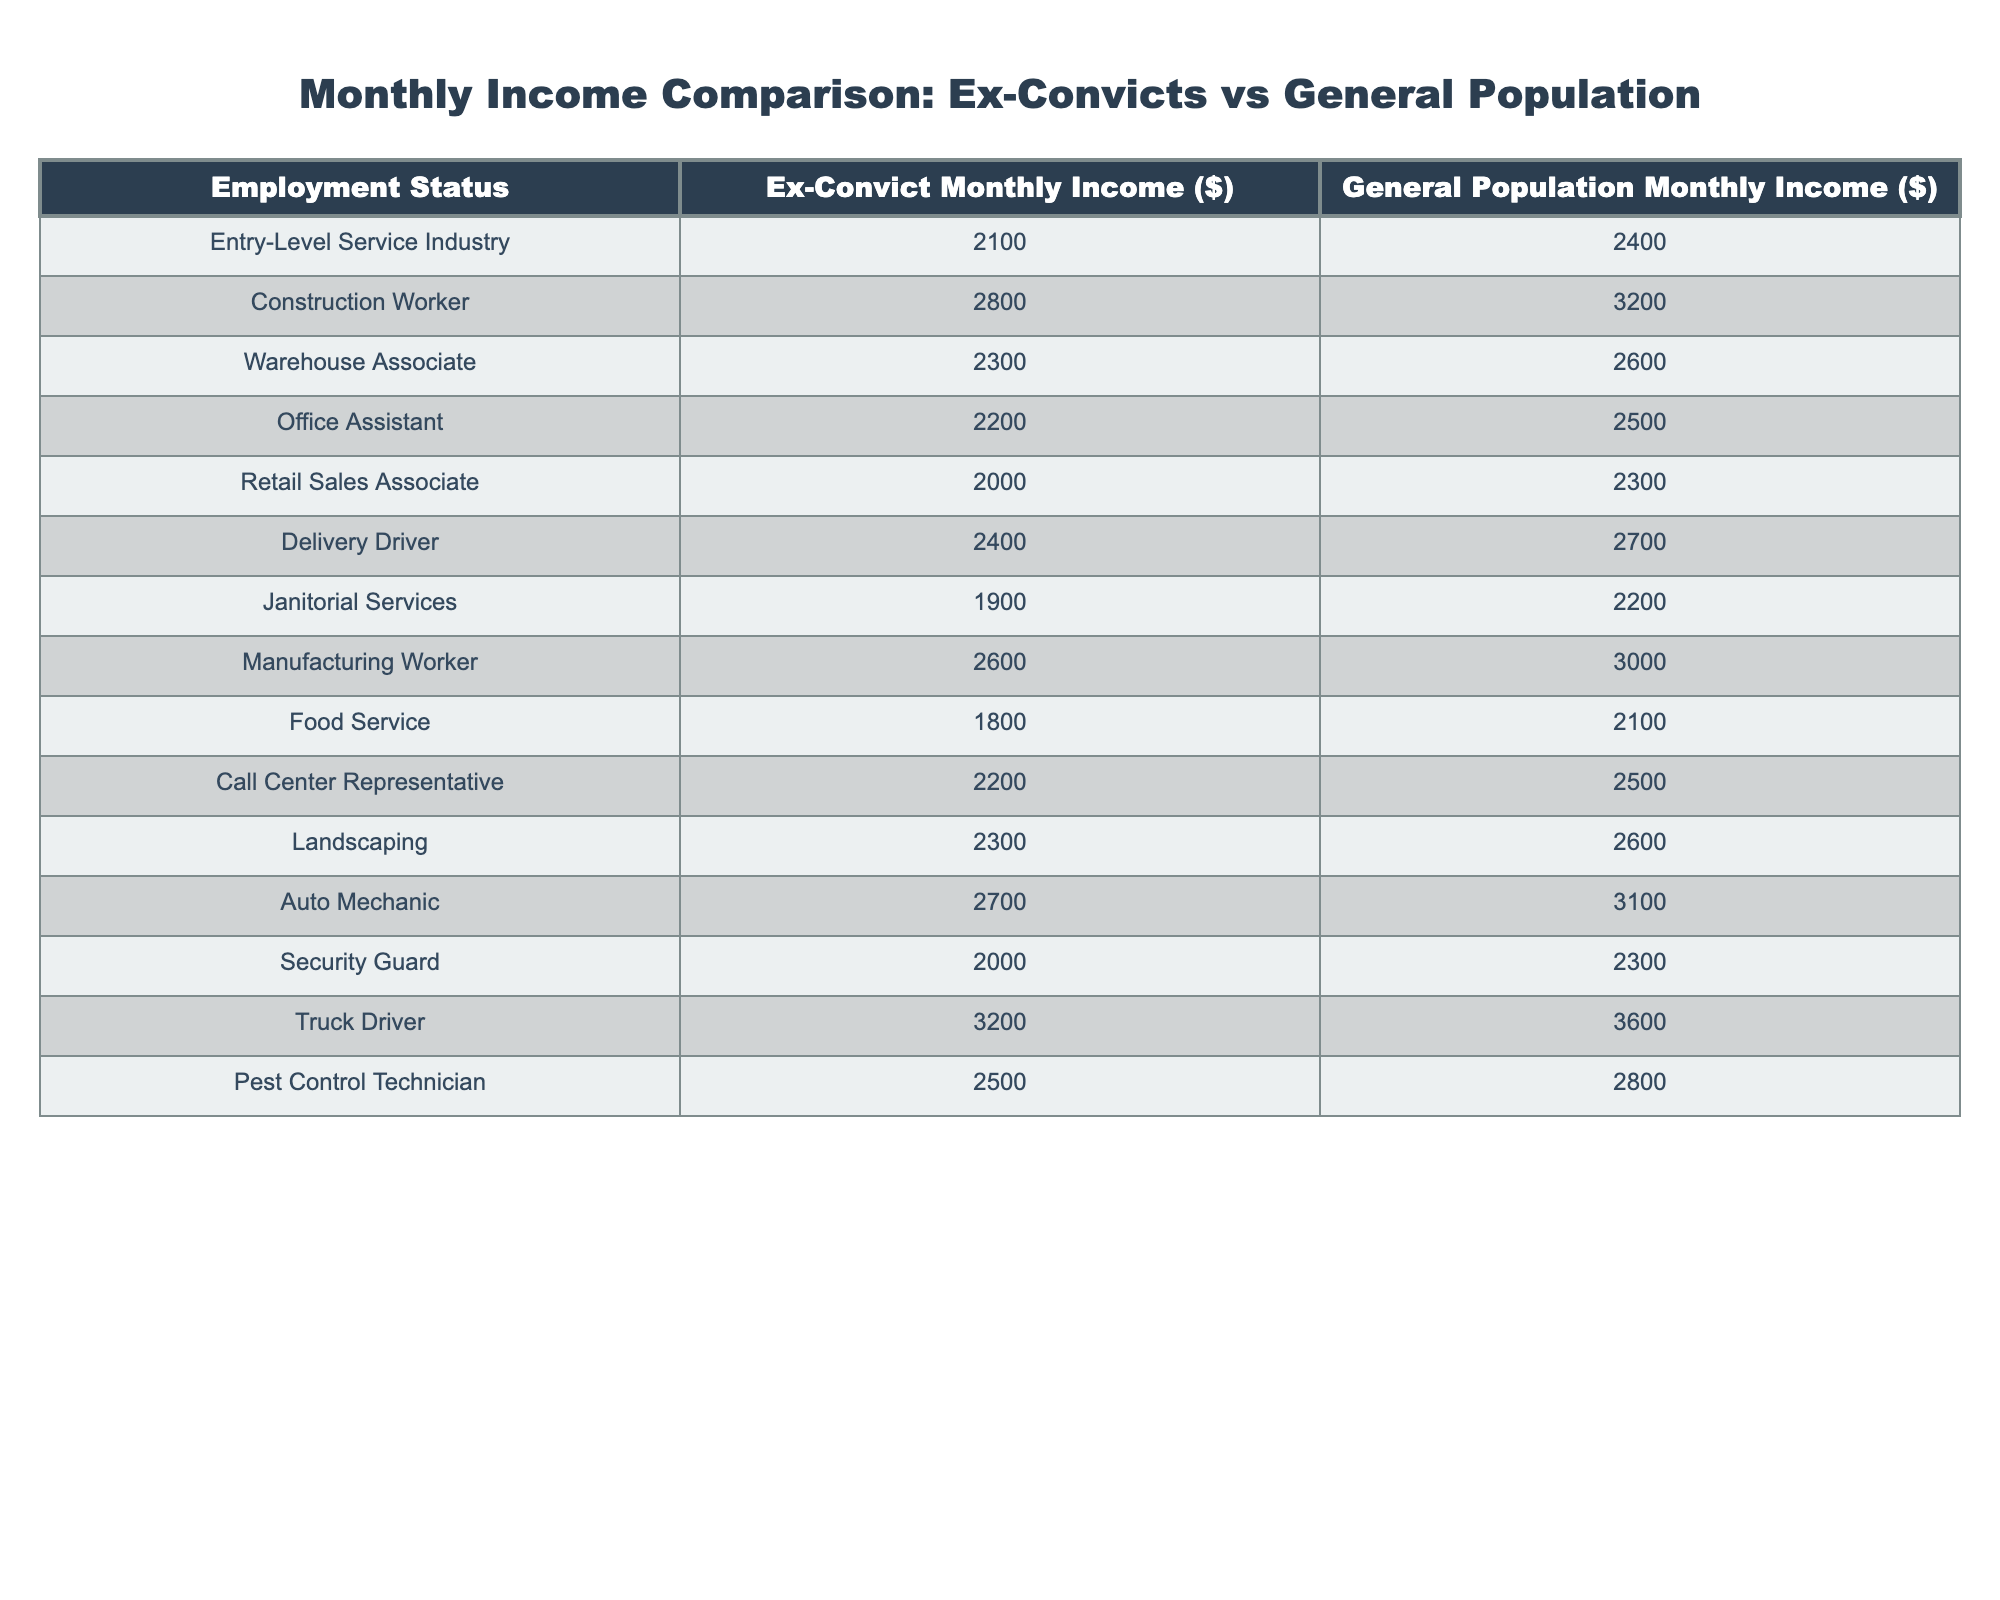What's the monthly income of a construction worker in the ex-convict group? The table indicates that the monthly income for a construction worker in the ex-convict group is $2800.
Answer: 2800 What is the monthly income of a delivery driver in the general population? According to the table, the monthly income for a delivery driver in the general population is $2700.
Answer: 2700 Which occupation for ex-convicts has the lowest monthly income? The table shows that the occupation with the lowest monthly income for ex-convicts is food service, earning $1800.
Answer: Food service What is the difference in monthly income between ex-convicts and the general population for retail sales associates? The table shows retail sales associates in the ex-convict group earn $2000, while the general population earns $2300. The difference is $2300 - $2000 = $300.
Answer: 300 What is the average monthly income of ex-convicts across all listed occupations? To find the average income, sum all the ex-convict incomes ($2100 + $2800 + $2300 + $2200 + $2000 + $2400 + $1900 + $2600 + $1800 + $2200 + $2300 + $2700 + $2000 + $3200 + $2500 = $32000) and divide by the number of occupations (15). This gives an average of $32000 / 15 = $2133.33.
Answer: 2133.33 Is the monthly income of a pest control technician higher than that of a warehouse associate in the ex-convict group? The monthly income for a pest control technician is $2500, while for a warehouse associate it is $2300. Since $2500 is greater than $2300, the statement is true.
Answer: Yes Comparing the monthly income of ex-convicts in the manufacturing and landscaping professions, which is higher? From the table, manufacturing workers earn $2600 and landscaping earns $2300. Since $2600 is greater than $2300, manufacturing has a higher income.
Answer: Manufacturing What is the total monthly income earned by a truck driver in both groups? The monthly income for ex-convicts truck drivers is $3200 and for the general population it is $3600. The total is $3200 + $3600 = $6800.
Answer: 6800 Is it true that the average monthly income of ex-convicts is greater than $2000? The average calculated previously was $2133.33, which is greater than $2000. Therefore, the statement is true.
Answer: Yes What is the highest monthly income reported for the general population? The table indicates that the highest monthly income for the general population is for truck drivers at $3600.
Answer: 3600 What's the percentage difference in income for janitorial services between ex-convicts and the general population? The income for janitorial services is $1900 for ex-convicts and $2200 for the general population. The percentage difference can be calculated as ((2200 - 1900) / 2200) * 100 = (300 / 2200) * 100 ≈ 13.64%.
Answer: 13.64% 